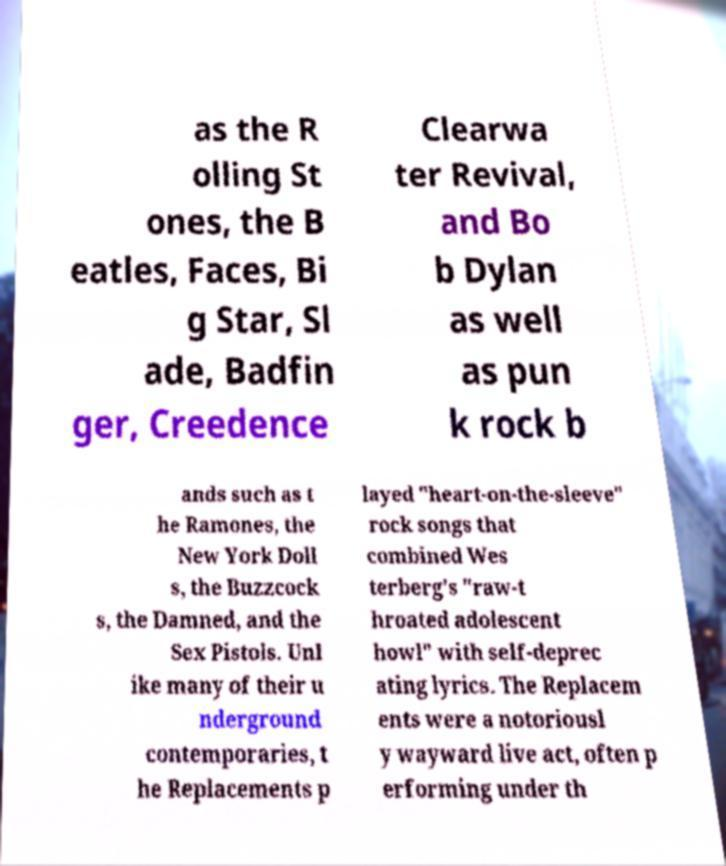Could you extract and type out the text from this image? as the R olling St ones, the B eatles, Faces, Bi g Star, Sl ade, Badfin ger, Creedence Clearwa ter Revival, and Bo b Dylan as well as pun k rock b ands such as t he Ramones, the New York Doll s, the Buzzcock s, the Damned, and the Sex Pistols. Unl ike many of their u nderground contemporaries, t he Replacements p layed "heart-on-the-sleeve" rock songs that combined Wes terberg's "raw-t hroated adolescent howl" with self-deprec ating lyrics. The Replacem ents were a notoriousl y wayward live act, often p erforming under th 